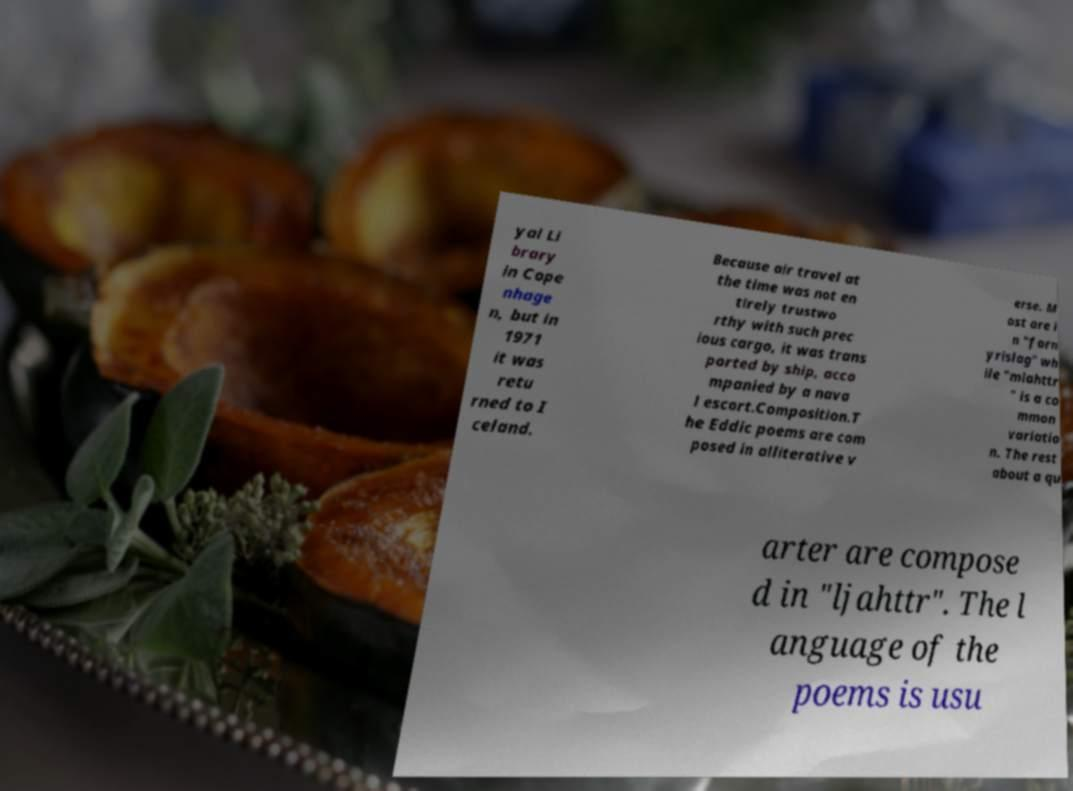Can you accurately transcribe the text from the provided image for me? yal Li brary in Cope nhage n, but in 1971 it was retu rned to I celand. Because air travel at the time was not en tirely trustwo rthy with such prec ious cargo, it was trans ported by ship, acco mpanied by a nava l escort.Composition.T he Eddic poems are com posed in alliterative v erse. M ost are i n "forn yrislag" wh ile "mlahttr " is a co mmon variatio n. The rest about a qu arter are compose d in "ljahttr". The l anguage of the poems is usu 